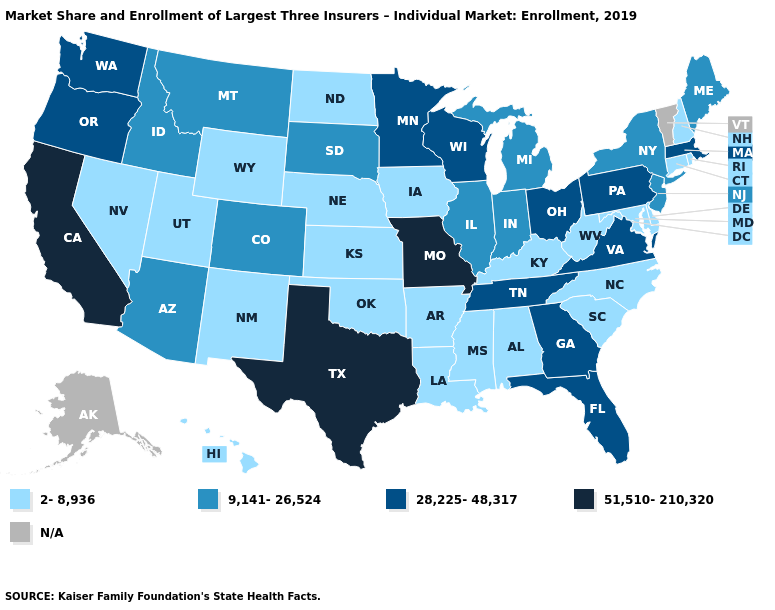What is the highest value in states that border Wisconsin?
Give a very brief answer. 28,225-48,317. Among the states that border New Mexico , does Texas have the highest value?
Be succinct. Yes. Does Michigan have the lowest value in the MidWest?
Write a very short answer. No. What is the highest value in states that border Florida?
Give a very brief answer. 28,225-48,317. What is the highest value in states that border Connecticut?
Write a very short answer. 28,225-48,317. Name the states that have a value in the range 51,510-210,320?
Keep it brief. California, Missouri, Texas. What is the value of South Carolina?
Write a very short answer. 2-8,936. What is the lowest value in the USA?
Be succinct. 2-8,936. Does the first symbol in the legend represent the smallest category?
Keep it brief. Yes. Does California have the lowest value in the USA?
Answer briefly. No. Name the states that have a value in the range N/A?
Be succinct. Alaska, Vermont. What is the lowest value in states that border Indiana?
Concise answer only. 2-8,936. Which states have the highest value in the USA?
Answer briefly. California, Missouri, Texas. 